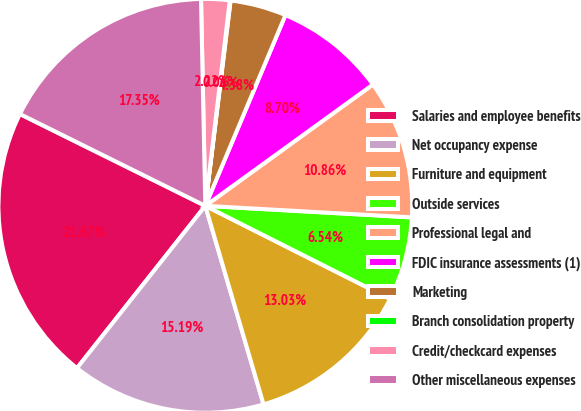Convert chart. <chart><loc_0><loc_0><loc_500><loc_500><pie_chart><fcel>Salaries and employee benefits<fcel>Net occupancy expense<fcel>Furniture and equipment<fcel>Outside services<fcel>Professional legal and<fcel>FDIC insurance assessments (1)<fcel>Marketing<fcel>Branch consolidation property<fcel>Credit/checkcard expenses<fcel>Other miscellaneous expenses<nl><fcel>21.67%<fcel>15.19%<fcel>13.03%<fcel>6.54%<fcel>10.86%<fcel>8.7%<fcel>4.38%<fcel>0.06%<fcel>2.22%<fcel>17.35%<nl></chart> 